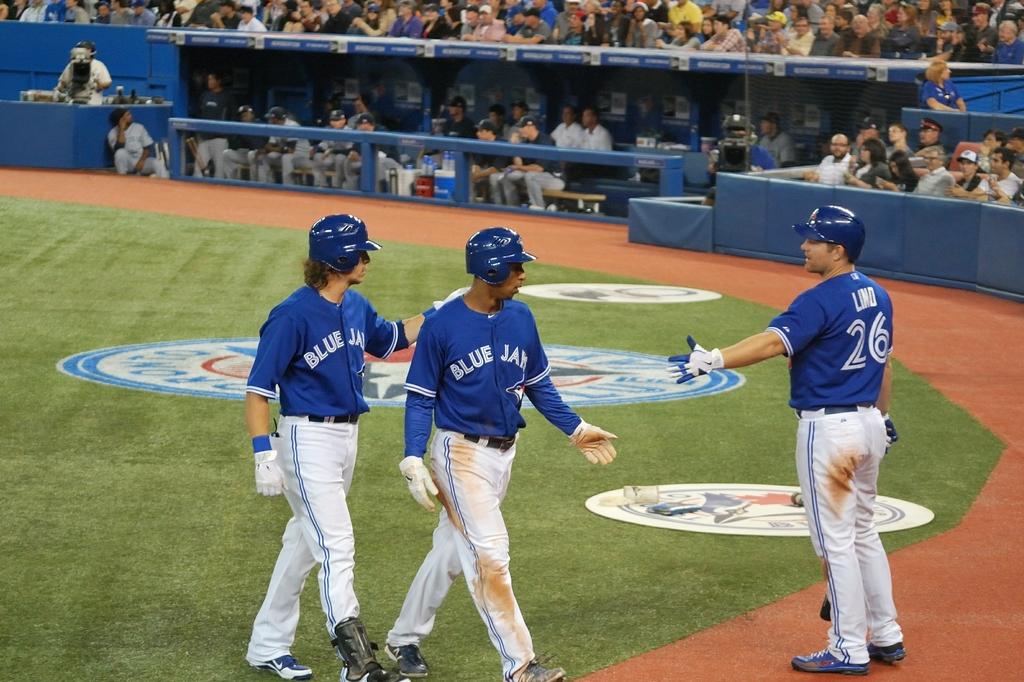What team are these players associated with?
Keep it short and to the point. Blue jays. What is player number 26's name?
Offer a very short reply. Lind. 